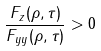Convert formula to latex. <formula><loc_0><loc_0><loc_500><loc_500>\frac { F _ { z } ( \rho , \tau ) } { F _ { y y } ( \rho , \tau ) } > 0</formula> 